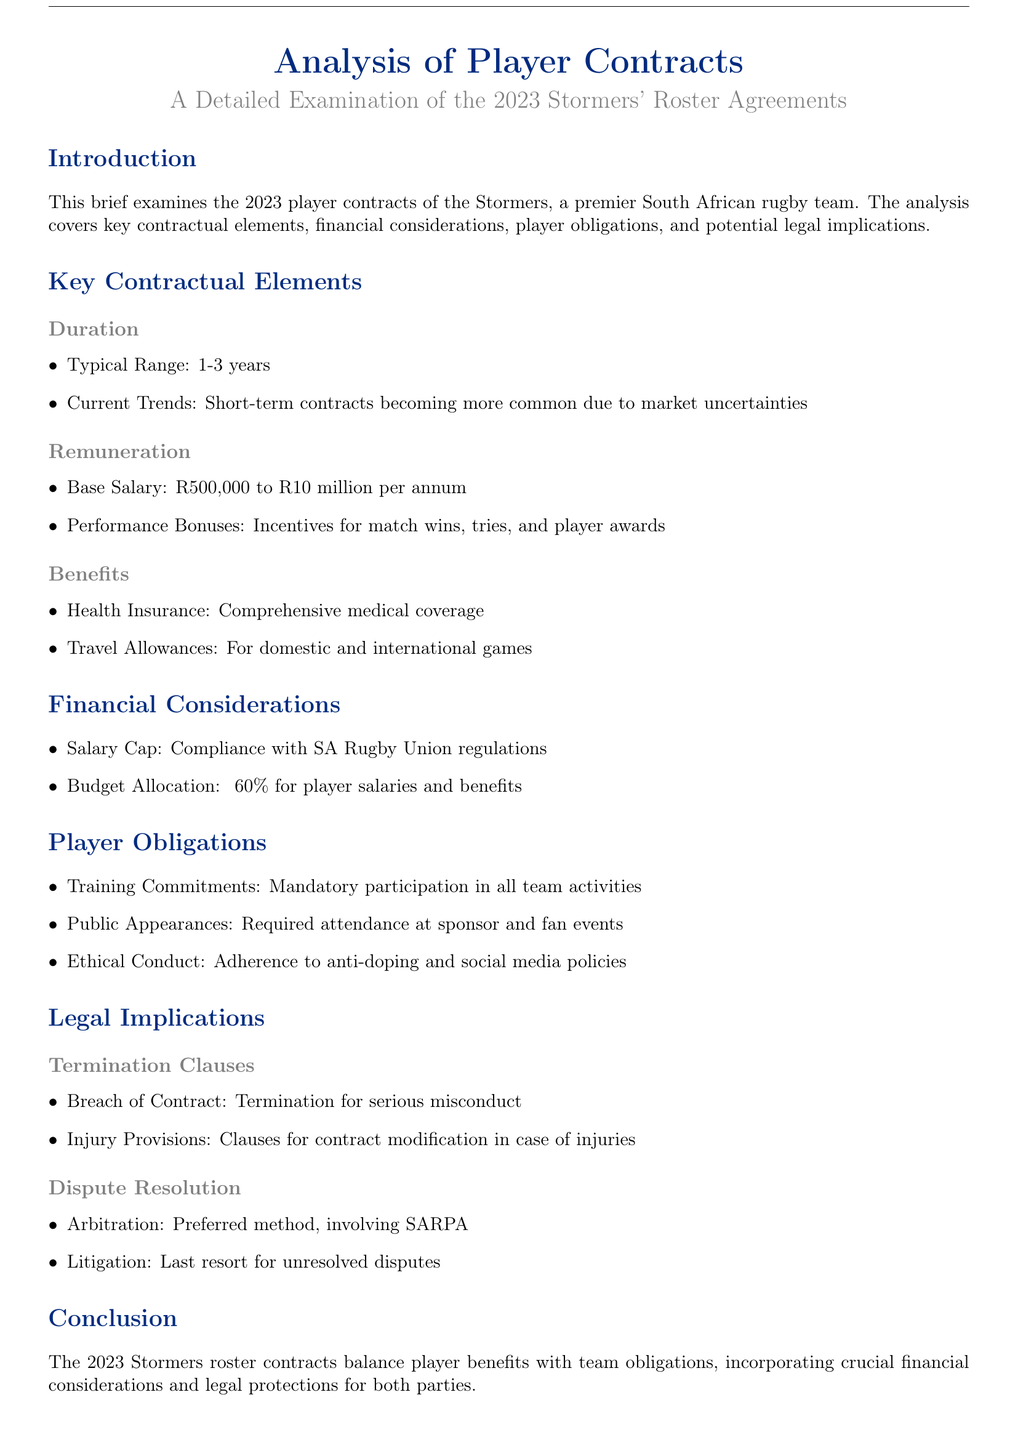What is the typical contract duration? The typical contract duration for players is usually between 1-3 years.
Answer: 1-3 years What is the base salary range for 2023 Stormers players? The base salary range for players is between R500,000 to R10 million per annum.
Answer: R500,000 to R10 million What is the percentage of the budget allocated for player salaries and benefits? The document states that approximately 60% of the budget is allocated for player salaries and benefits.
Answer: 60% What is a mandatory player obligation mentioned in the document? Players are required to participate in all team activities as a training commitment.
Answer: Training Commitments What is the preferred method for dispute resolution? The preferred method for resolving disputes as noted in the document is arbitration involving SARPA.
Answer: Arbitration What benefits do players receive according to the contracts? Players receive comprehensive medical coverage and travel allowances for games.
Answer: Health Insurance and Travel Allowances What can lead to termination of a player's contract? Serious misconduct is cited as a breach of contract that can lead to termination.
Answer: Breach of Contract What is the document's focus in relation to the Stormers? The document focuses on the analysis of player contracts for the 2023 Stormers' roster agreements.
Answer: Analysis of Player Contracts How are performance bonuses related to player contracts? Performance bonuses are incentives tied to match wins, tries, and player awards.
Answer: Incentives for match wins, tries, and player awards 